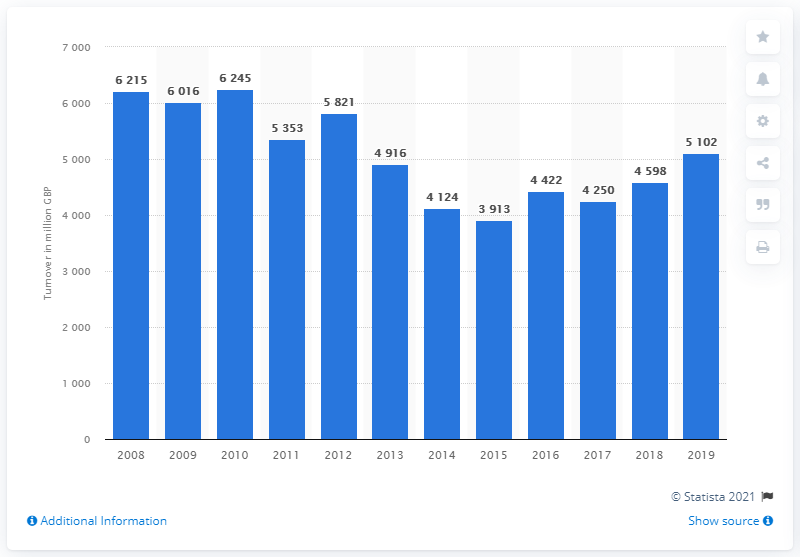List a handful of essential elements in this visual. The revenue generated from audio and visual equipment in 2013 was 4916. In 2019, the turnover of retail sales of audio and visual equipment in the UK was 5102. 